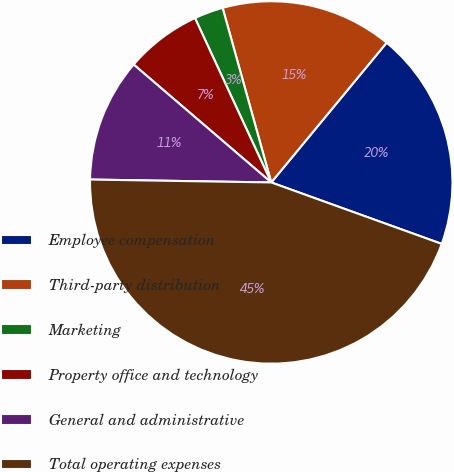Convert chart to OTSL. <chart><loc_0><loc_0><loc_500><loc_500><pie_chart><fcel>Employee compensation<fcel>Third-party distribution<fcel>Marketing<fcel>Property office and technology<fcel>General and administrative<fcel>Total operating expenses<nl><fcel>19.52%<fcel>15.31%<fcel>2.59%<fcel>6.81%<fcel>11.02%<fcel>44.75%<nl></chart> 